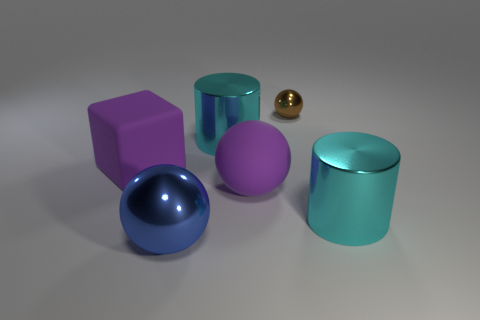Is there a large matte sphere that has the same color as the cube?
Your answer should be very brief. Yes. There is a big cube; how many cyan cylinders are in front of it?
Your response must be concise. 1. What number of tiny purple cubes are there?
Your answer should be very brief. 0. Do the matte ball and the brown shiny sphere have the same size?
Your answer should be very brief. No. There is a big ball that is behind the cyan metallic object that is to the right of the small shiny sphere; are there any large purple rubber objects behind it?
Offer a terse response. Yes. There is a tiny brown object that is the same shape as the blue metal thing; what material is it?
Your response must be concise. Metal. The tiny thing that is behind the large matte sphere is what color?
Your answer should be very brief. Brown. What is the size of the brown object?
Provide a succinct answer. Small. There is a blue metallic ball; does it have the same size as the metallic sphere on the right side of the large rubber sphere?
Offer a very short reply. No. What is the color of the thing that is behind the cylinder that is behind the cyan metal thing that is in front of the purple matte block?
Ensure brevity in your answer.  Brown. 